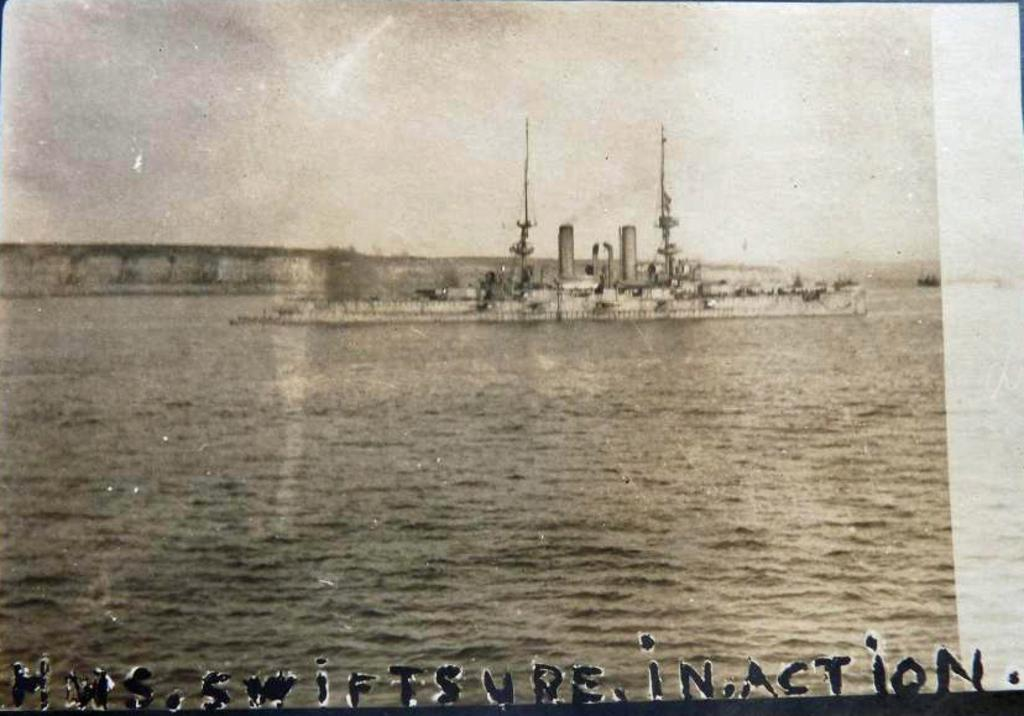What is the main subject in the image? There is a ship in the image. What is the primary element in the image? There is water in the image. What type of apparatus is being used for the competition in the image? There is no apparatus or competition present in the image; it features a ship on water. 